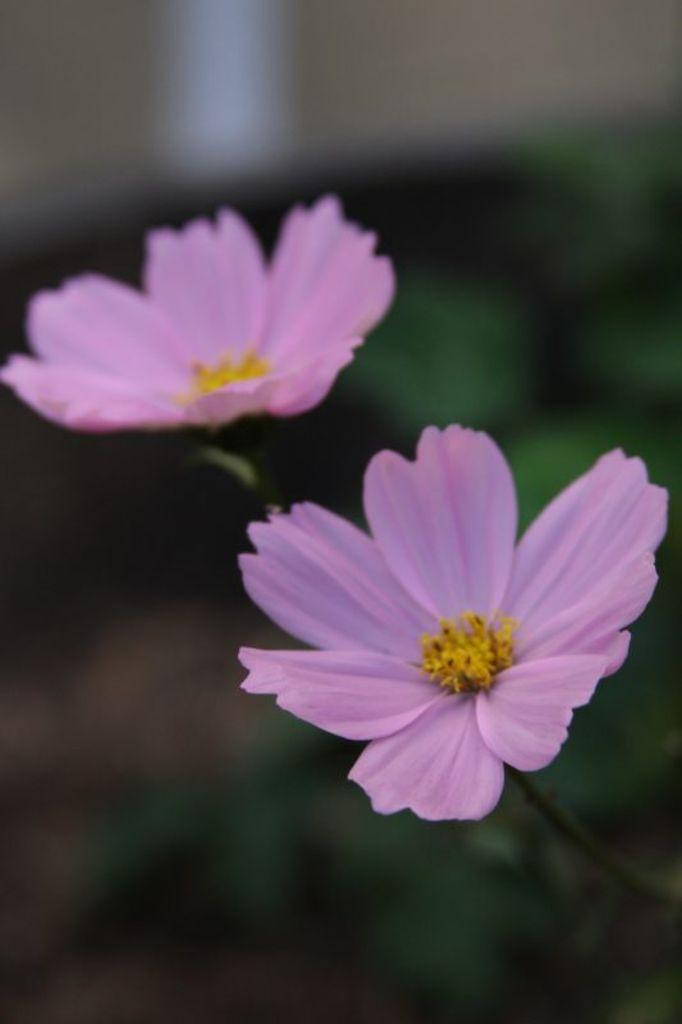How many flowers can be seen in the image? There are two flowers in the image. What part of the flowers is visible besides the petals? The flowers have stems in the image. Can you describe the background of the image? The background of the image has a blurred view. What color is present in the image? The color green is present in the image. How many prisoners are visible in the image? There are no prisoners present in the image; it features two flowers with stems and a blurred background. Can you tell me how many buns are being held by the ladybug in the image? There is no ladybug present in the image, and therefore no buns can be observed. 